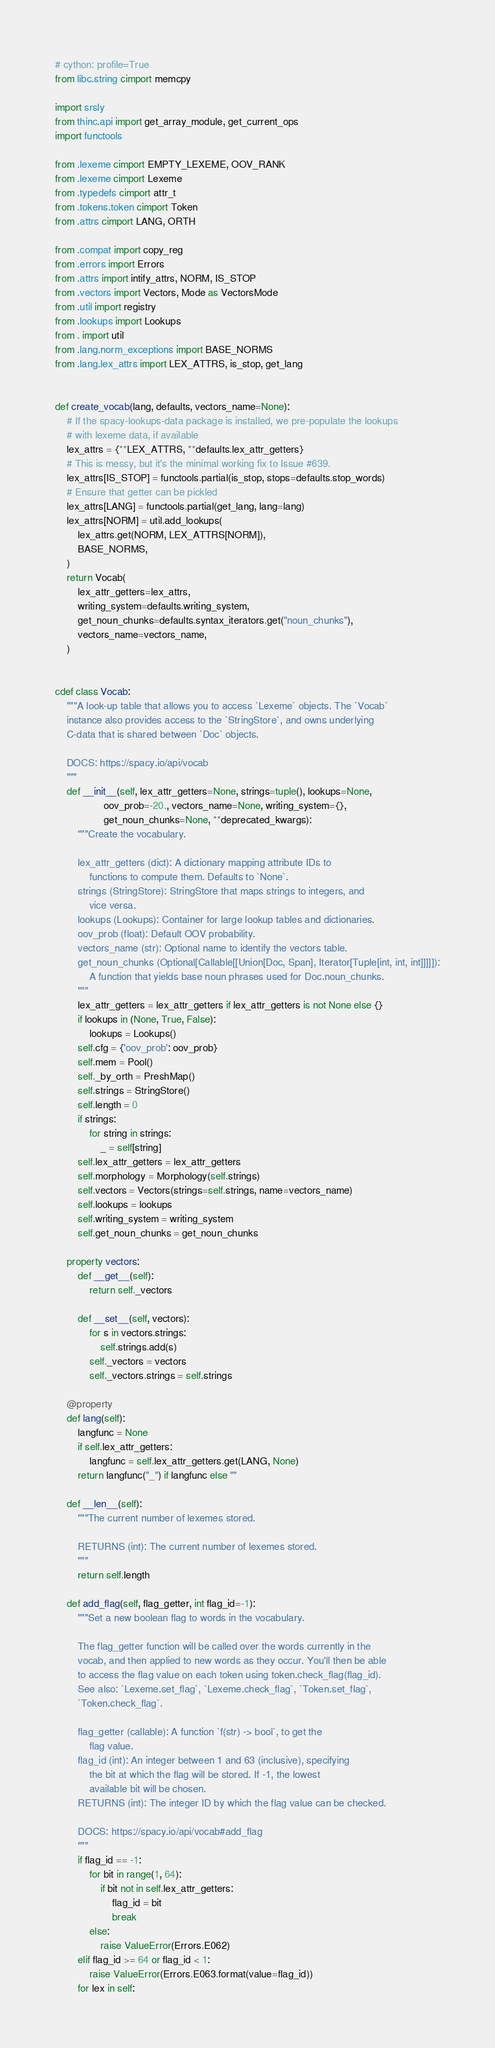Convert code to text. <code><loc_0><loc_0><loc_500><loc_500><_Cython_># cython: profile=True
from libc.string cimport memcpy

import srsly
from thinc.api import get_array_module, get_current_ops
import functools

from .lexeme cimport EMPTY_LEXEME, OOV_RANK
from .lexeme cimport Lexeme
from .typedefs cimport attr_t
from .tokens.token cimport Token
from .attrs cimport LANG, ORTH

from .compat import copy_reg
from .errors import Errors
from .attrs import intify_attrs, NORM, IS_STOP
from .vectors import Vectors, Mode as VectorsMode
from .util import registry
from .lookups import Lookups
from . import util
from .lang.norm_exceptions import BASE_NORMS
from .lang.lex_attrs import LEX_ATTRS, is_stop, get_lang


def create_vocab(lang, defaults, vectors_name=None):
    # If the spacy-lookups-data package is installed, we pre-populate the lookups
    # with lexeme data, if available
    lex_attrs = {**LEX_ATTRS, **defaults.lex_attr_getters}
    # This is messy, but it's the minimal working fix to Issue #639.
    lex_attrs[IS_STOP] = functools.partial(is_stop, stops=defaults.stop_words)
    # Ensure that getter can be pickled
    lex_attrs[LANG] = functools.partial(get_lang, lang=lang)
    lex_attrs[NORM] = util.add_lookups(
        lex_attrs.get(NORM, LEX_ATTRS[NORM]),
        BASE_NORMS,
    )
    return Vocab(
        lex_attr_getters=lex_attrs,
        writing_system=defaults.writing_system,
        get_noun_chunks=defaults.syntax_iterators.get("noun_chunks"),
        vectors_name=vectors_name,
    )


cdef class Vocab:
    """A look-up table that allows you to access `Lexeme` objects. The `Vocab`
    instance also provides access to the `StringStore`, and owns underlying
    C-data that is shared between `Doc` objects.

    DOCS: https://spacy.io/api/vocab
    """
    def __init__(self, lex_attr_getters=None, strings=tuple(), lookups=None,
                 oov_prob=-20., vectors_name=None, writing_system={},
                 get_noun_chunks=None, **deprecated_kwargs):
        """Create the vocabulary.

        lex_attr_getters (dict): A dictionary mapping attribute IDs to
            functions to compute them. Defaults to `None`.
        strings (StringStore): StringStore that maps strings to integers, and
            vice versa.
        lookups (Lookups): Container for large lookup tables and dictionaries.
        oov_prob (float): Default OOV probability.
        vectors_name (str): Optional name to identify the vectors table.
        get_noun_chunks (Optional[Callable[[Union[Doc, Span], Iterator[Tuple[int, int, int]]]]]):
            A function that yields base noun phrases used for Doc.noun_chunks.
        """
        lex_attr_getters = lex_attr_getters if lex_attr_getters is not None else {}
        if lookups in (None, True, False):
            lookups = Lookups()
        self.cfg = {'oov_prob': oov_prob}
        self.mem = Pool()
        self._by_orth = PreshMap()
        self.strings = StringStore()
        self.length = 0
        if strings:
            for string in strings:
                _ = self[string]
        self.lex_attr_getters = lex_attr_getters
        self.morphology = Morphology(self.strings)
        self.vectors = Vectors(strings=self.strings, name=vectors_name)
        self.lookups = lookups
        self.writing_system = writing_system
        self.get_noun_chunks = get_noun_chunks

    property vectors:
        def __get__(self):
            return self._vectors

        def __set__(self, vectors):
            for s in vectors.strings:
                self.strings.add(s)
            self._vectors = vectors
            self._vectors.strings = self.strings

    @property
    def lang(self):
        langfunc = None
        if self.lex_attr_getters:
            langfunc = self.lex_attr_getters.get(LANG, None)
        return langfunc("_") if langfunc else ""

    def __len__(self):
        """The current number of lexemes stored.

        RETURNS (int): The current number of lexemes stored.
        """
        return self.length

    def add_flag(self, flag_getter, int flag_id=-1):
        """Set a new boolean flag to words in the vocabulary.

        The flag_getter function will be called over the words currently in the
        vocab, and then applied to new words as they occur. You'll then be able
        to access the flag value on each token using token.check_flag(flag_id).
        See also: `Lexeme.set_flag`, `Lexeme.check_flag`, `Token.set_flag`,
        `Token.check_flag`.

        flag_getter (callable): A function `f(str) -> bool`, to get the
            flag value.
        flag_id (int): An integer between 1 and 63 (inclusive), specifying
            the bit at which the flag will be stored. If -1, the lowest
            available bit will be chosen.
        RETURNS (int): The integer ID by which the flag value can be checked.

        DOCS: https://spacy.io/api/vocab#add_flag
        """
        if flag_id == -1:
            for bit in range(1, 64):
                if bit not in self.lex_attr_getters:
                    flag_id = bit
                    break
            else:
                raise ValueError(Errors.E062)
        elif flag_id >= 64 or flag_id < 1:
            raise ValueError(Errors.E063.format(value=flag_id))
        for lex in self:</code> 